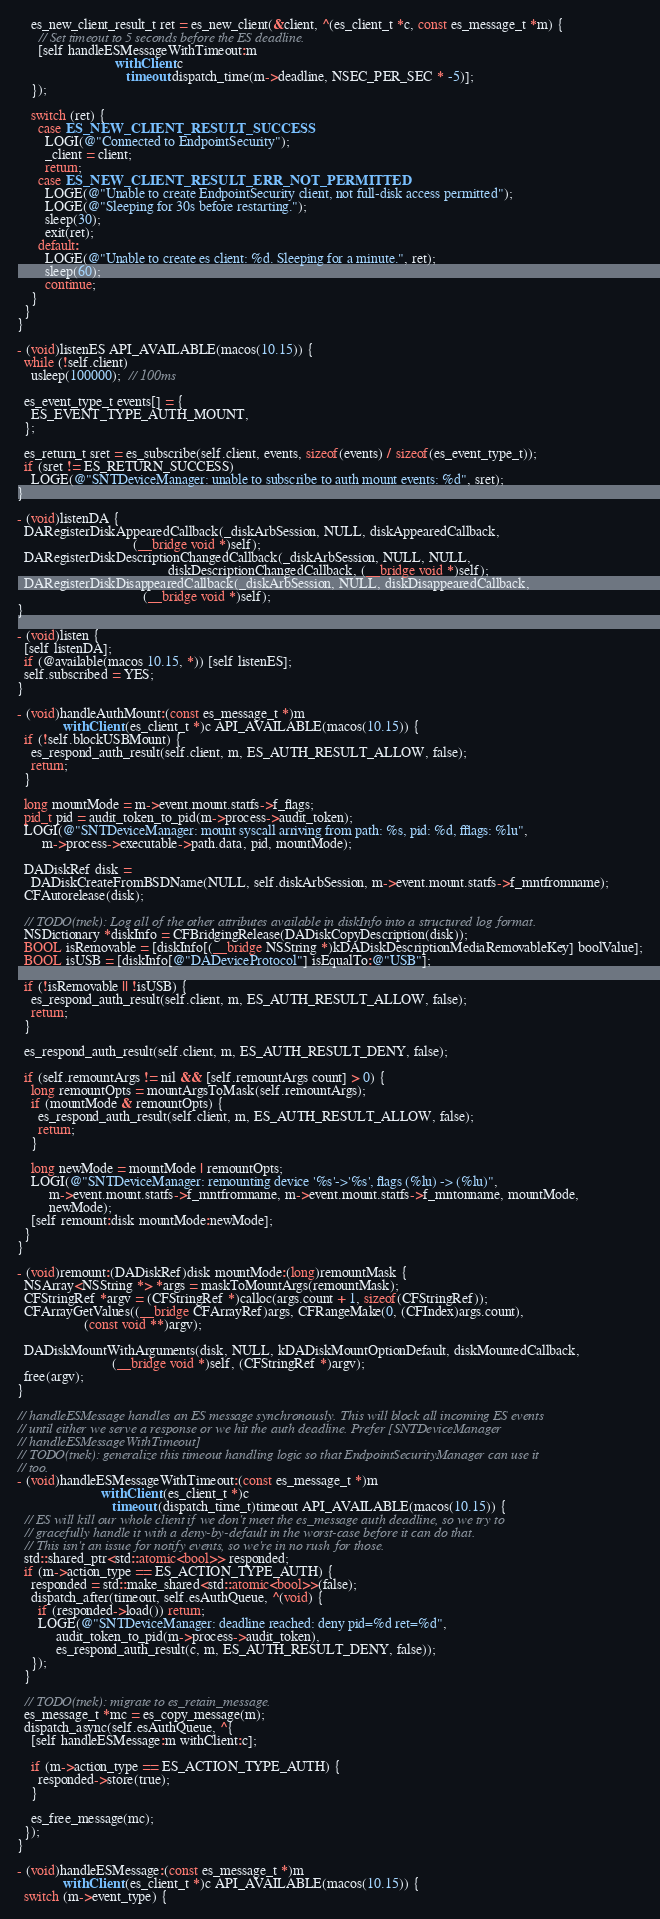<code> <loc_0><loc_0><loc_500><loc_500><_ObjectiveC_>    es_new_client_result_t ret = es_new_client(&client, ^(es_client_t *c, const es_message_t *m) {
      // Set timeout to 5 seconds before the ES deadline.
      [self handleESMessageWithTimeout:m
                            withClient:c
                               timeout:dispatch_time(m->deadline, NSEC_PER_SEC * -5)];
    });

    switch (ret) {
      case ES_NEW_CLIENT_RESULT_SUCCESS:
        LOGI(@"Connected to EndpointSecurity");
        _client = client;
        return;
      case ES_NEW_CLIENT_RESULT_ERR_NOT_PERMITTED:
        LOGE(@"Unable to create EndpointSecurity client, not full-disk access permitted");
        LOGE(@"Sleeping for 30s before restarting.");
        sleep(30);
        exit(ret);
      default:
        LOGE(@"Unable to create es client: %d. Sleeping for a minute.", ret);
        sleep(60);
        continue;
    }
  }
}

- (void)listenES API_AVAILABLE(macos(10.15)) {
  while (!self.client)
    usleep(100000);  // 100ms

  es_event_type_t events[] = {
    ES_EVENT_TYPE_AUTH_MOUNT,
  };

  es_return_t sret = es_subscribe(self.client, events, sizeof(events) / sizeof(es_event_type_t));
  if (sret != ES_RETURN_SUCCESS)
    LOGE(@"SNTDeviceManager: unable to subscribe to auth mount events: %d", sret);
}

- (void)listenDA {
  DARegisterDiskAppearedCallback(_diskArbSession, NULL, diskAppearedCallback,
                                 (__bridge void *)self);
  DARegisterDiskDescriptionChangedCallback(_diskArbSession, NULL, NULL,
                                           diskDescriptionChangedCallback, (__bridge void *)self);
  DARegisterDiskDisappearedCallback(_diskArbSession, NULL, diskDisappearedCallback,
                                    (__bridge void *)self);
}

- (void)listen {
  [self listenDA];
  if (@available(macos 10.15, *)) [self listenES];
  self.subscribed = YES;
}

- (void)handleAuthMount:(const es_message_t *)m
             withClient:(es_client_t *)c API_AVAILABLE(macos(10.15)) {
  if (!self.blockUSBMount) {
    es_respond_auth_result(self.client, m, ES_AUTH_RESULT_ALLOW, false);
    return;
  }

  long mountMode = m->event.mount.statfs->f_flags;
  pid_t pid = audit_token_to_pid(m->process->audit_token);
  LOGI(@"SNTDeviceManager: mount syscall arriving from path: %s, pid: %d, fflags: %lu",
       m->process->executable->path.data, pid, mountMode);

  DADiskRef disk =
    DADiskCreateFromBSDName(NULL, self.diskArbSession, m->event.mount.statfs->f_mntfromname);
  CFAutorelease(disk);

  // TODO(tnek): Log all of the other attributes available in diskInfo into a structured log format.
  NSDictionary *diskInfo = CFBridgingRelease(DADiskCopyDescription(disk));
  BOOL isRemovable = [diskInfo[(__bridge NSString *)kDADiskDescriptionMediaRemovableKey] boolValue];
  BOOL isUSB = [diskInfo[@"DADeviceProtocol"] isEqualTo:@"USB"];

  if (!isRemovable || !isUSB) {
    es_respond_auth_result(self.client, m, ES_AUTH_RESULT_ALLOW, false);
    return;
  }

  es_respond_auth_result(self.client, m, ES_AUTH_RESULT_DENY, false);

  if (self.remountArgs != nil && [self.remountArgs count] > 0) {
    long remountOpts = mountArgsToMask(self.remountArgs);
    if (mountMode & remountOpts) {
      es_respond_auth_result(self.client, m, ES_AUTH_RESULT_ALLOW, false);
      return;
    }

    long newMode = mountMode | remountOpts;
    LOGI(@"SNTDeviceManager: remounting device '%s'->'%s', flags (%lu) -> (%lu)",
         m->event.mount.statfs->f_mntfromname, m->event.mount.statfs->f_mntonname, mountMode,
         newMode);
    [self remount:disk mountMode:newMode];
  }
}

- (void)remount:(DADiskRef)disk mountMode:(long)remountMask {
  NSArray<NSString *> *args = maskToMountArgs(remountMask);
  CFStringRef *argv = (CFStringRef *)calloc(args.count + 1, sizeof(CFStringRef));
  CFArrayGetValues((__bridge CFArrayRef)args, CFRangeMake(0, (CFIndex)args.count),
                   (const void **)argv);

  DADiskMountWithArguments(disk, NULL, kDADiskMountOptionDefault, diskMountedCallback,
                           (__bridge void *)self, (CFStringRef *)argv);
  free(argv);
}

// handleESMessage handles an ES message synchronously. This will block all incoming ES events
// until either we serve a response or we hit the auth deadline. Prefer [SNTDeviceManager
// handleESMessageWithTimeout]
// TODO(tnek): generalize this timeout handling logic so that EndpointSecurityManager can use it
// too.
- (void)handleESMessageWithTimeout:(const es_message_t *)m
                        withClient:(es_client_t *)c
                           timeout:(dispatch_time_t)timeout API_AVAILABLE(macos(10.15)) {
  // ES will kill our whole client if we don't meet the es_message auth deadline, so we try to
  // gracefully handle it with a deny-by-default in the worst-case before it can do that.
  // This isn't an issue for notify events, so we're in no rush for those.
  std::shared_ptr<std::atomic<bool>> responded;
  if (m->action_type == ES_ACTION_TYPE_AUTH) {
    responded = std::make_shared<std::atomic<bool>>(false);
    dispatch_after(timeout, self.esAuthQueue, ^(void) {
      if (responded->load()) return;
      LOGE(@"SNTDeviceManager: deadline reached: deny pid=%d ret=%d",
           audit_token_to_pid(m->process->audit_token),
           es_respond_auth_result(c, m, ES_AUTH_RESULT_DENY, false));
    });
  }

  // TODO(tnek): migrate to es_retain_message.
  es_message_t *mc = es_copy_message(m);
  dispatch_async(self.esAuthQueue, ^{
    [self handleESMessage:m withClient:c];

    if (m->action_type == ES_ACTION_TYPE_AUTH) {
      responded->store(true);
    }

    es_free_message(mc);
  });
}

- (void)handleESMessage:(const es_message_t *)m
             withClient:(es_client_t *)c API_AVAILABLE(macos(10.15)) {
  switch (m->event_type) {</code> 